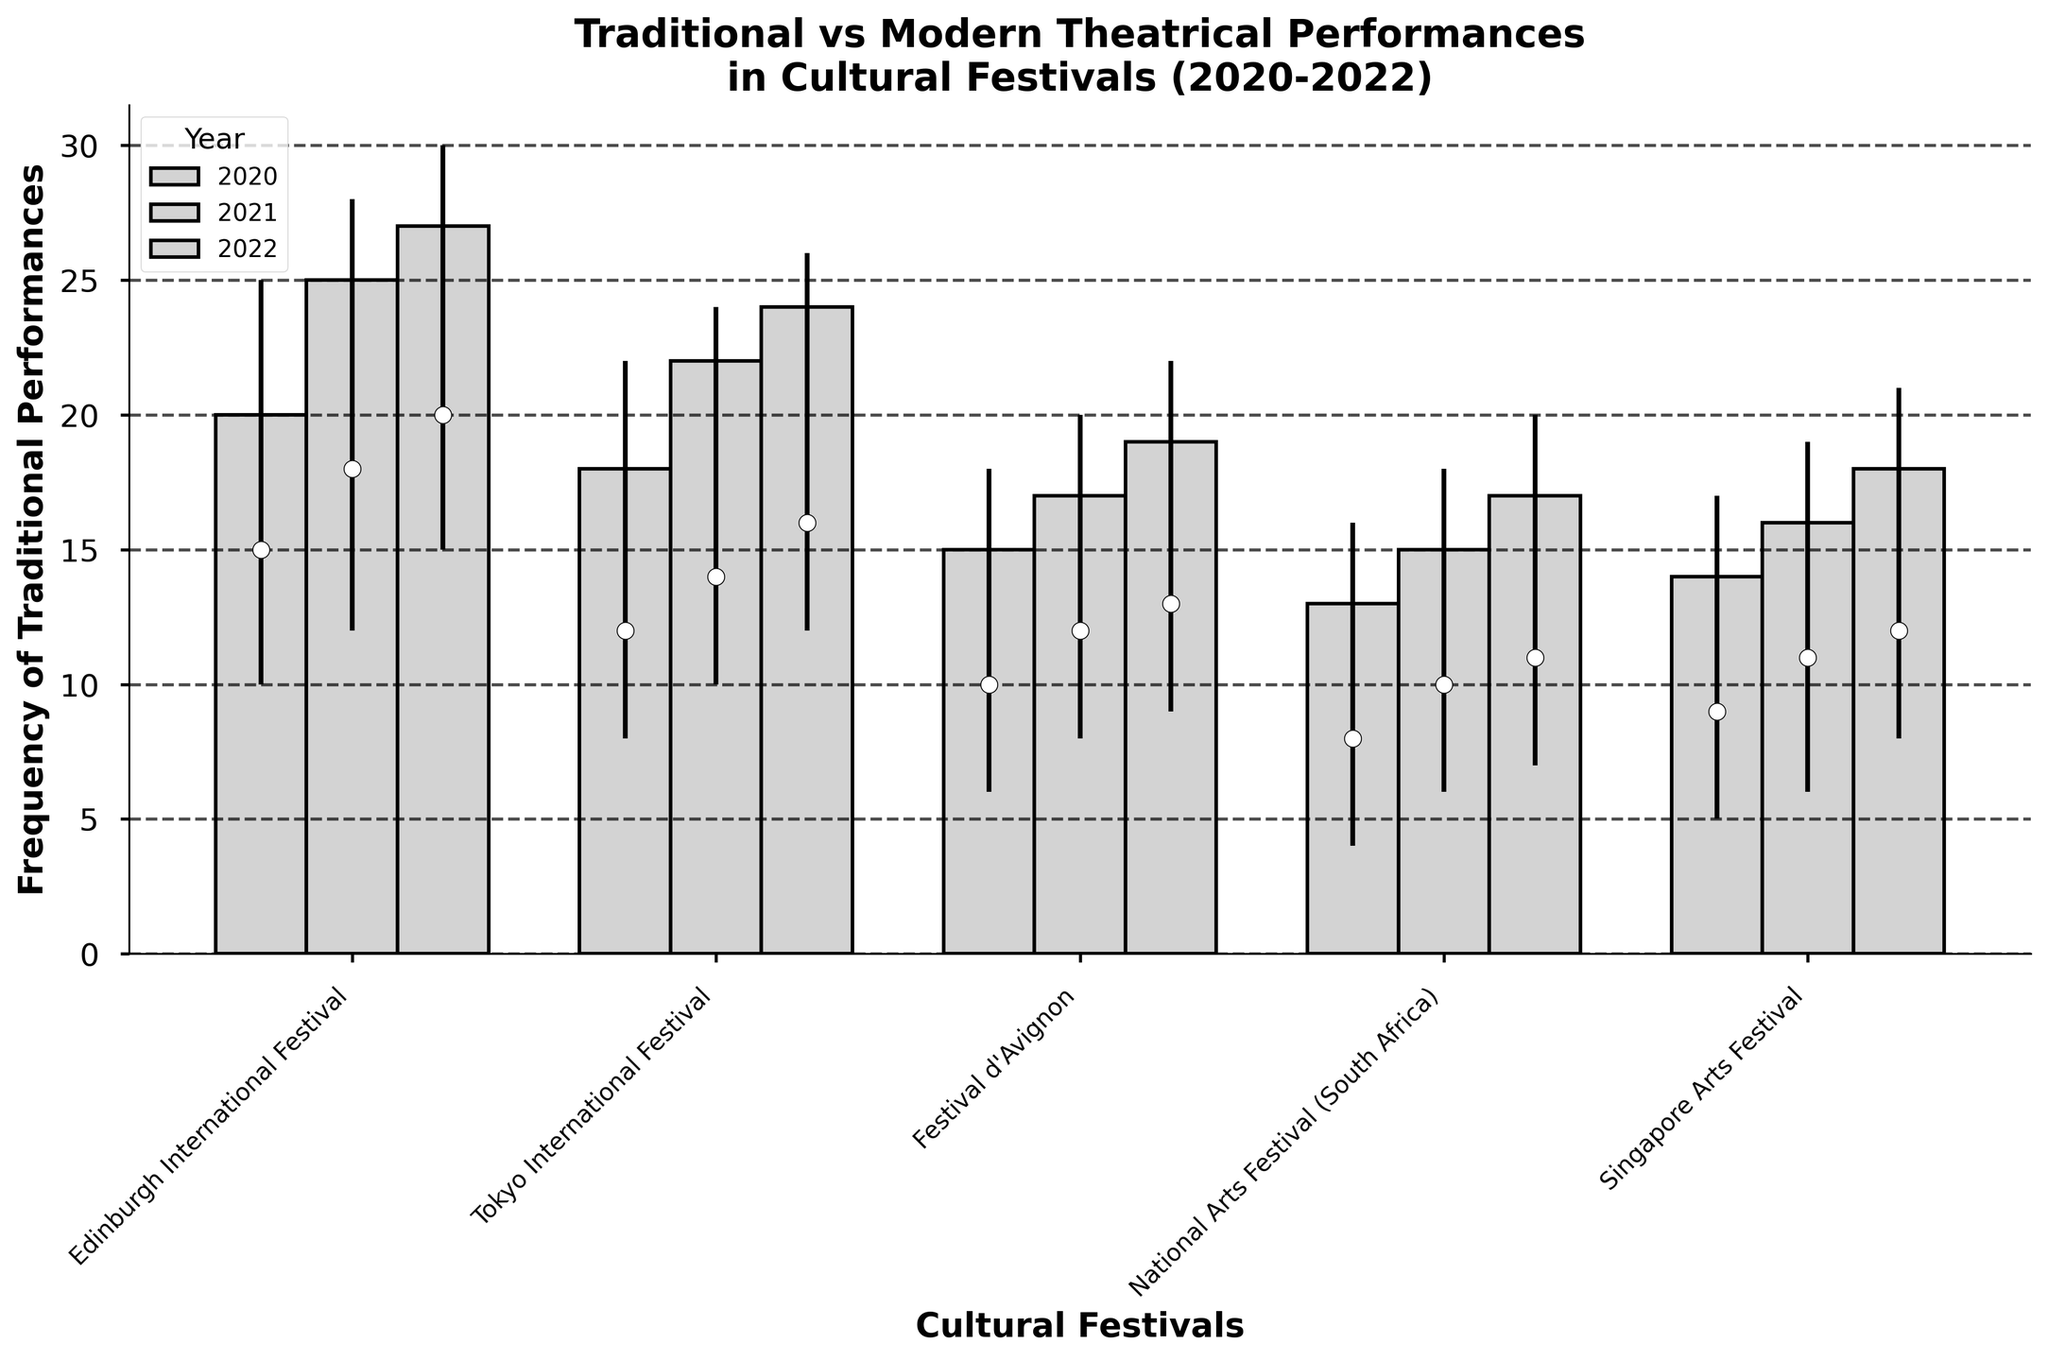what is the title of the figure? Look at the top of the figure, the title is usually written prominently.
Answer: Traditional vs Modern Theatrical Performances in Cultural Festivals (2020-2022) what is on the x-axis? The label on the x-axis indicates what is being measured horizontally.
Answer: Cultural Festivals how many cultural festivals are represented? Count the number of unique cultural festivals listed on the x-axis.
Answer: 5 which festival had the highest frequency of traditional performances in 2022? Observe the height of the bars for 2022, look for the tallest bar.
Answer: Edinburgh International Festival how many traditional performances were at the National Arts Festival in 2020 at its lowest point? Check the vertical line representing the 2020 data for the National Arts Festival and note the lowest point.
Answer: 4 what is the overall trend in traditional performances at the Singapore Arts Festival from 2020 to 2022? Compare the height of the bars for each year from 2020 to 2022 and observe if they are increasing, decreasing, or stable.
Answer: Increasing which festival shows the most consistent frequency of traditional performances over the years 2020-2022? Look for the festival with the least variation in bar heights and vertical lines across the years.
Answer: Tokyo International Festival how does the frequency of traditional performances in 2021 at the Festival d'Avignon compare to 2020? Find the bars for 2020 and 2021 for the Festival d'Avignon and compare their heights.
Answer: Higher in 2021 which year did the Edinburgh International Festival experience the highest high point for traditional performances? Look at the vertical lines for each year at the Edinburgh International Festival and identify the highest peak.
Answer: 2022 what is the average close value for the Tokyo International Festival across the three years? Add the close values for the Tokyo International Festival for 2020, 2021, and 2022, then divide by 3. (18 + 22 + 24) / 3 = 21.33
Answer: 21.33 